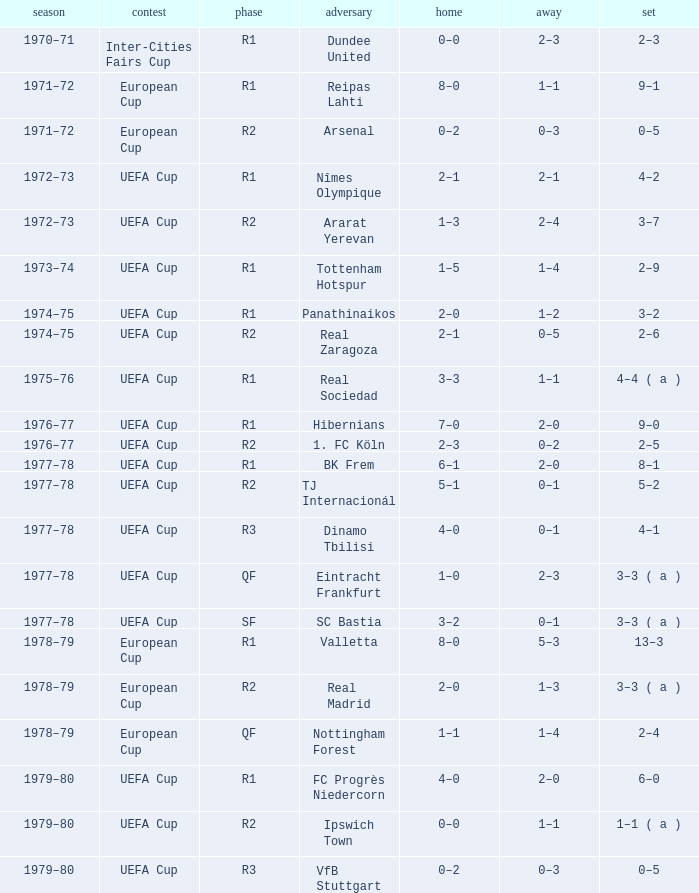Which Home has a Round of r1, and an Opponent of dundee united? 0–0. 